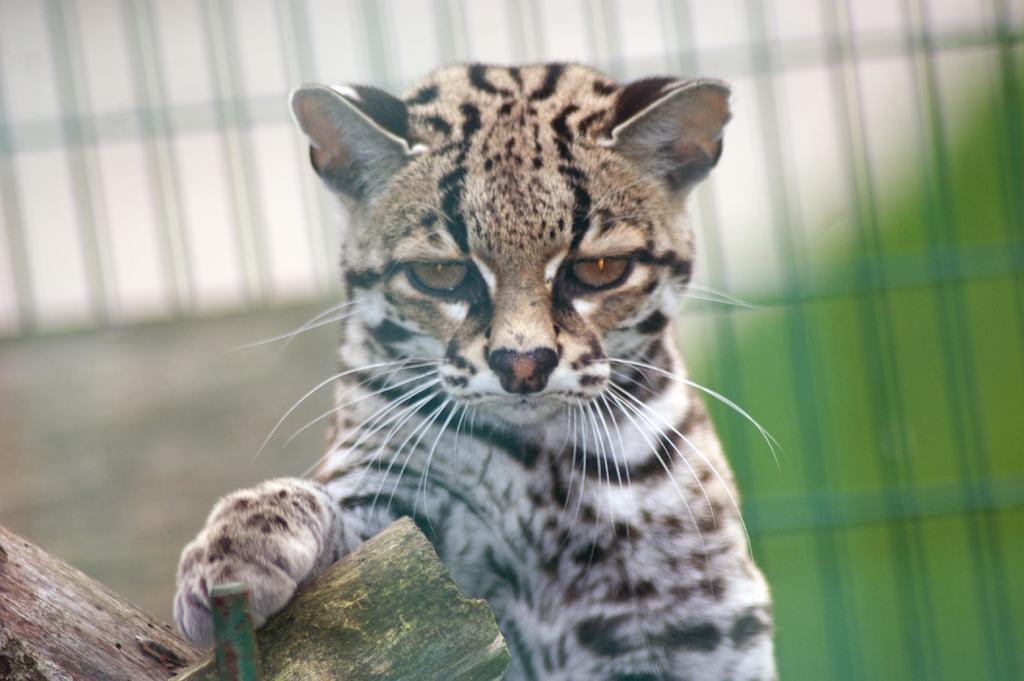Describe this image in one or two sentences. In this image I can see an animal in black,white and brown color. Background is green and white color and it is blurred. 